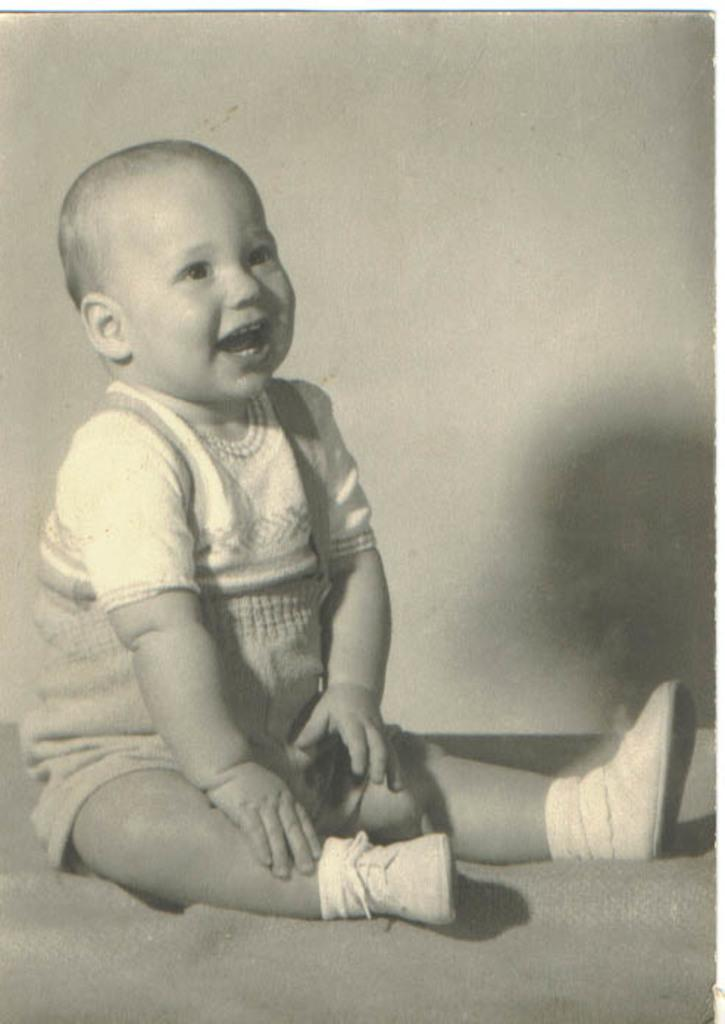What is the main subject of the image? There is a kid in the center of the image. What is the kid doing in the image? The kid is sitting. What is the emotional expression of the kid in the image? The kid appears to be smiling. What can be seen in the background of the image? There is an object in the background of the image. What additional detail can be observed about the object in the background? A shadow is visible on the object in the background. What type of patch is sewn onto the yoke of the kid's clothing in the image? There is no patch or yoke visible on the kid's clothing in the image. 